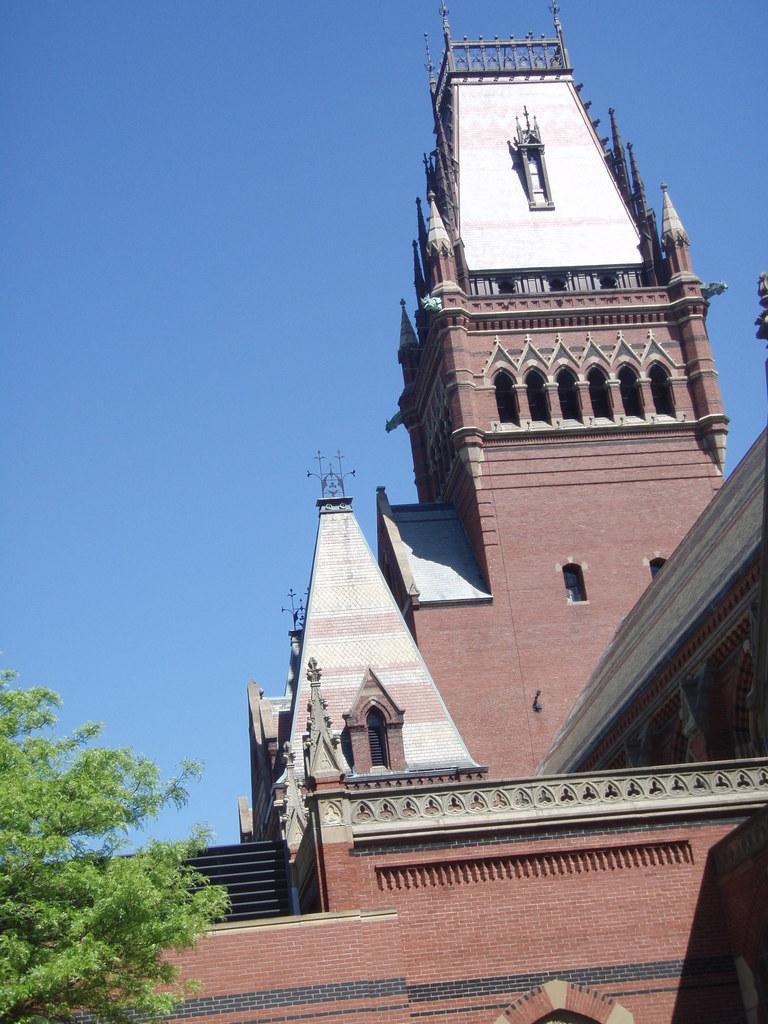In one or two sentences, can you explain what this image depicts? This picture is clicked outside. On the right we can see a building and on the left there is a tree. In the background there is a sky. 